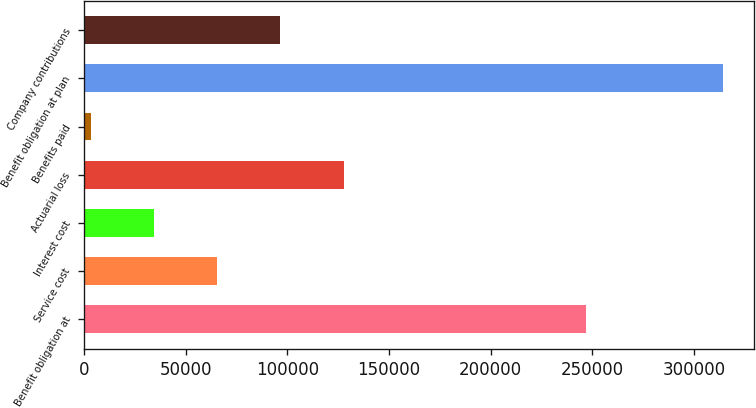Convert chart to OTSL. <chart><loc_0><loc_0><loc_500><loc_500><bar_chart><fcel>Benefit obligation at<fcel>Service cost<fcel>Interest cost<fcel>Actuarial loss<fcel>Benefits paid<fcel>Benefit obligation at plan<fcel>Company contributions<nl><fcel>246985<fcel>65500.6<fcel>34418.8<fcel>127664<fcel>3337<fcel>314155<fcel>96582.4<nl></chart> 